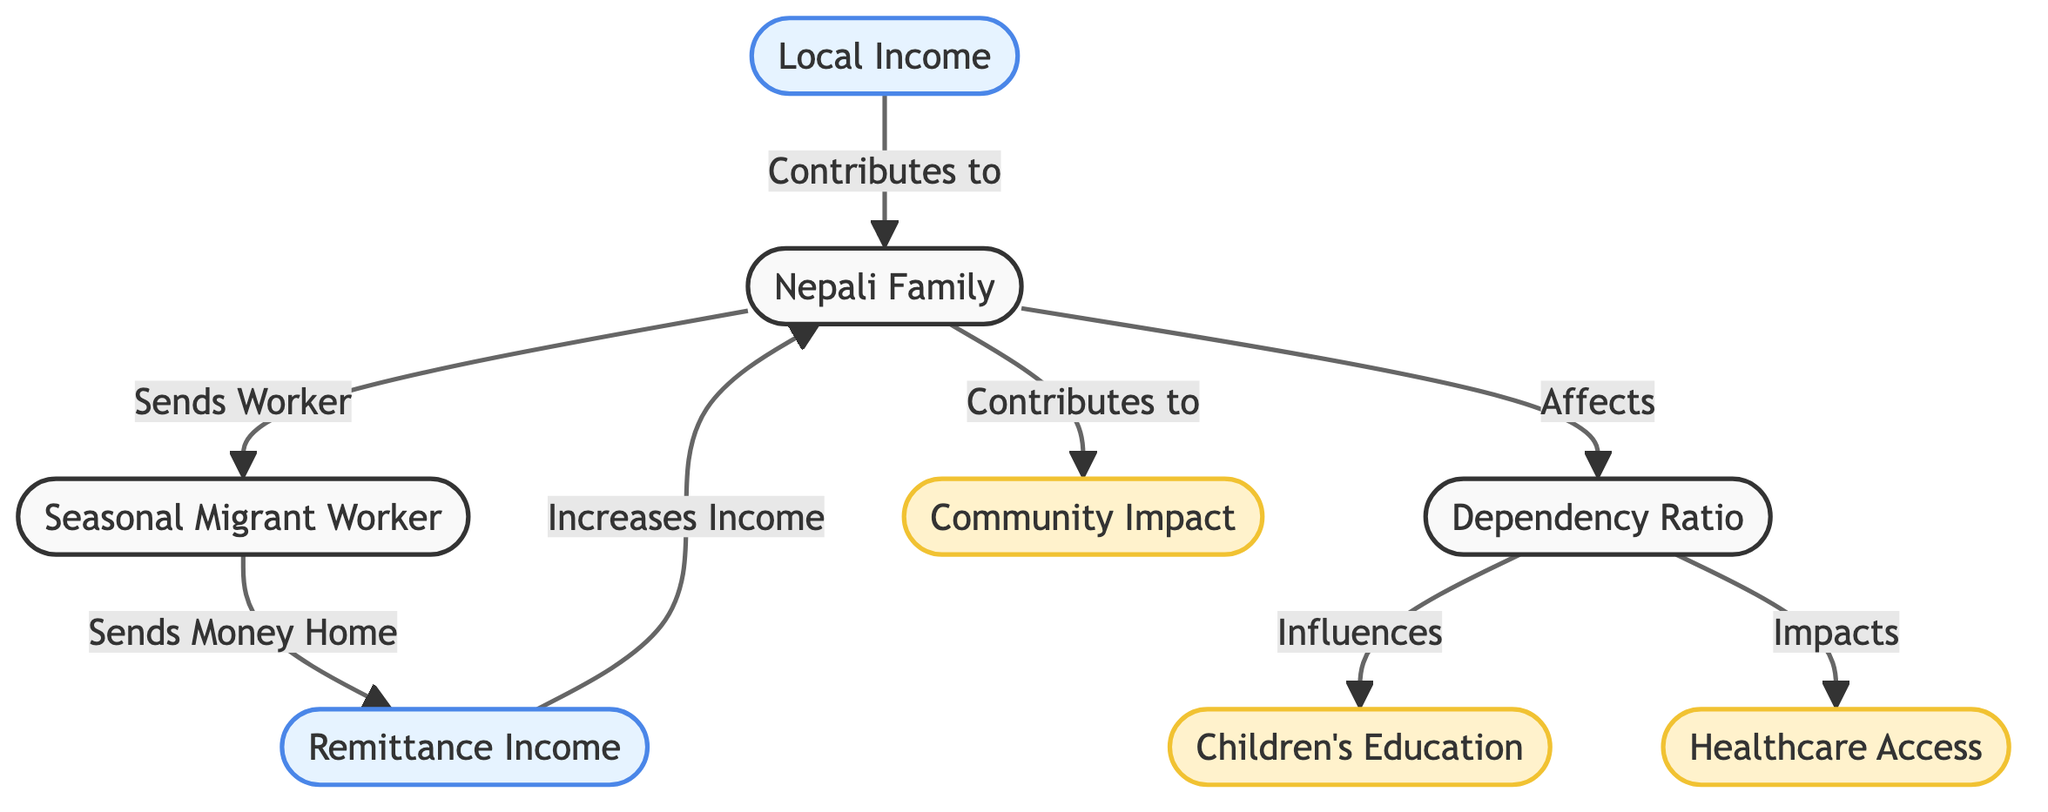What is the primary source of income for the Nepali family? The diagram indicates that the primary source of income for the family is from both local income and remittance income. However, remittance income is specifically highlighted as an increase in income derived from the seasonal migrant worker.
Answer: Remittance Income How does the dependency ratio affect children's education? The diagram shows that the dependency ratio influences children's education. Thus, a higher dependency ratio could potentially result in less funding or lower educational opportunities for children, as resources are stretched.
Answer: Influences What contributes to the community impact? According to the diagram, contributions to community impact stem from the entire family. The family’s involvement in local income and remittance income also indirectly supports community development, but the node specifies family contributions as key.
Answer: Family What happens to the family when a migrant worker sends money home? The diagram illustrates that when a migrant worker sends money home, it directly increases the family’s income through remittance income, thereby impacting their financial stability and quality of life.
Answer: Increases Income How many main factors are shown impacting healthcare in the diagram? The diagram shows one main factor directly impacting healthcare, which is the dependency ratio. The relationship indicates that as the dependency ratio changes, healthcare access is influenced.
Answer: One What is the connection between the dependency ratio and local income? The diagram does not specifically indicate a direct connection between dependency ratio and local income since local income contributes to the family independently, while the dependency ratio is influenced by family dynamics and external income sources. Therefore, there is an indirect relationship, but not a direct effect shown.
Answer: No direct connection How is the income of the Nepali family affected by seasonal migration? Seasonal migration allows one family member to become a migrant worker, sending back remittance income, which increases the family income. Local income remains part of this financial structure. Thus, seasonal migration directly improves the family’s income through remittance.
Answer: Increases Income What two major categories of income contribute to the Nepali family's financial status? The diagram identifies two main categories contributing to the family’s financial status: remittance income and local income. Both sources are vital in understanding the overall income landscape of the family.
Answer: Remittance Income and Local Income 